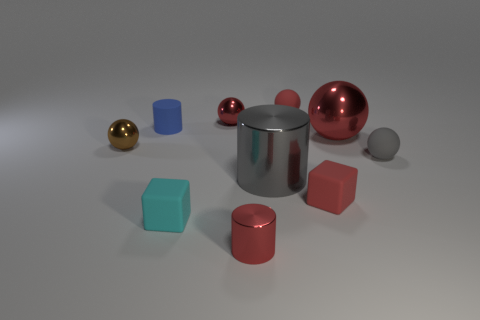Is there a cyan sphere that has the same size as the matte cylinder?
Make the answer very short. No. There is a brown thing that is the same size as the rubber cylinder; what is it made of?
Make the answer very short. Metal. What is the size of the sphere behind the red metal sphere behind the blue rubber object?
Your answer should be compact. Small. There is a red metal thing in front of the cyan matte thing; is its size the same as the matte cylinder?
Keep it short and to the point. Yes. Is the number of gray balls that are to the left of the gray metallic object greater than the number of cyan cubes behind the gray ball?
Your answer should be very brief. No. The matte object that is to the right of the matte cylinder and to the left of the small shiny cylinder has what shape?
Your answer should be very brief. Cube. What shape is the object that is left of the small blue matte cylinder?
Make the answer very short. Sphere. What size is the gray object that is on the left side of the gray ball right of the small metal thing that is behind the tiny brown metallic thing?
Keep it short and to the point. Large. Is the small gray rubber thing the same shape as the tiny brown shiny object?
Make the answer very short. Yes. What size is the metallic ball that is both behind the tiny brown sphere and left of the large red shiny ball?
Provide a succinct answer. Small. 